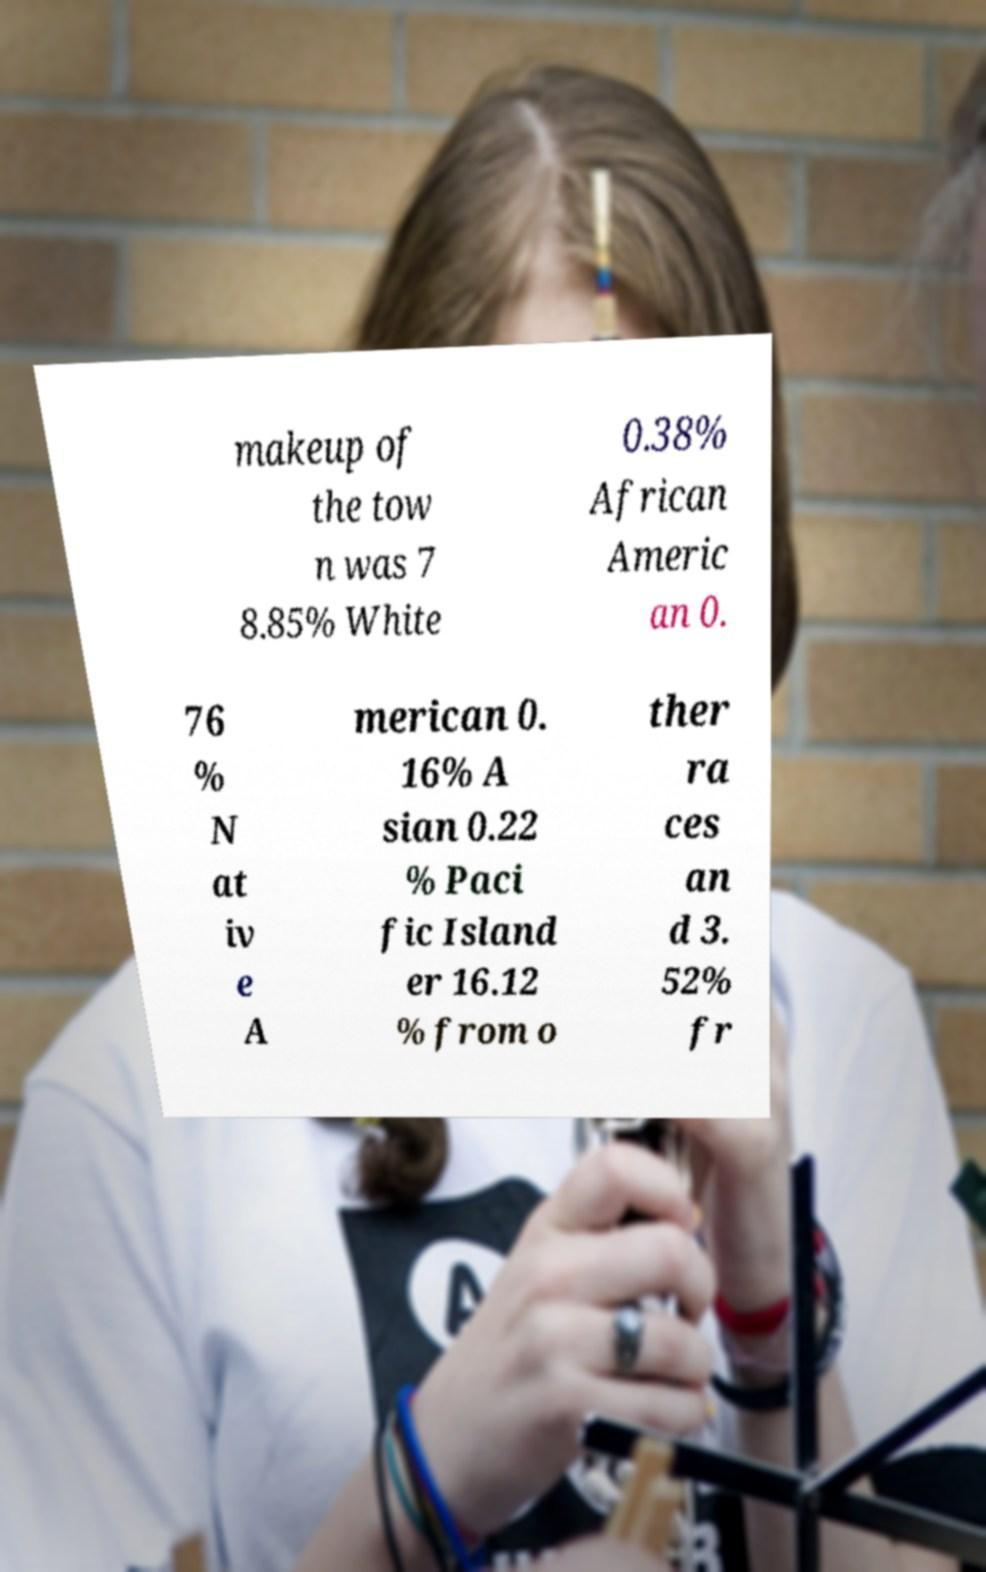Please identify and transcribe the text found in this image. makeup of the tow n was 7 8.85% White 0.38% African Americ an 0. 76 % N at iv e A merican 0. 16% A sian 0.22 % Paci fic Island er 16.12 % from o ther ra ces an d 3. 52% fr 